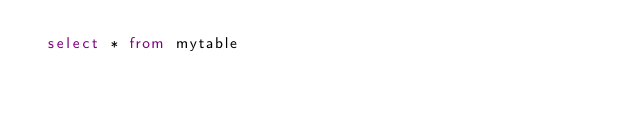<code> <loc_0><loc_0><loc_500><loc_500><_SQL_> select * from mytable

</code> 